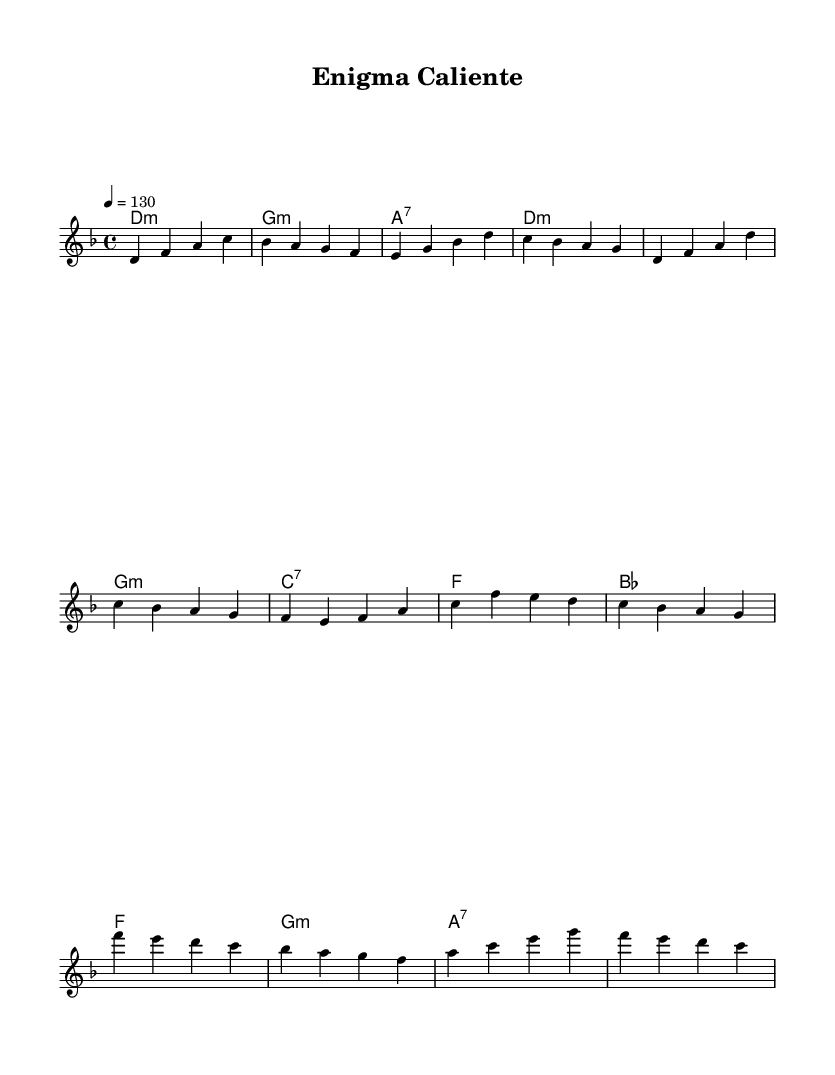What is the key signature of this music? The key signature is D minor, indicated by the one flat (B flat) listed alongside the clef.
Answer: D minor What is the time signature of this music? The time signature is 4/4, shown at the beginning of the music as a fraction that signifies four beats in a measure.
Answer: 4/4 What is the tempo marking of this piece? The tempo marking is set to 130 beats per minute, indicated by the "4 = 130" notation alongside the tempo indication.
Answer: 130 How many measures are there in the melody part? The melody part has a total of 12 measures, as counted from the section layout, since it includes an introductory and verse section as well as a chorus.
Answer: 12 What type of seventh chord is used in the chorus? The chord used in the chorus is an A7 chord, clearly marked with the "a:7" label in the harmonies section.
Answer: A7 What rhythmic pattern is most dominant throughout this piece? The rhythmic pattern is consistently in quarter notes, as all notes shown are quarter notes aligning with the 4/4 time signature facilitating a smooth rhythmic flow.
Answer: Quarter notes What style of music does this sheet represent? This music represents Latin jazz fusion, characterized by a blend of Latin rhythms and jazz harmonies within its structure and style.
Answer: Latin jazz fusion 